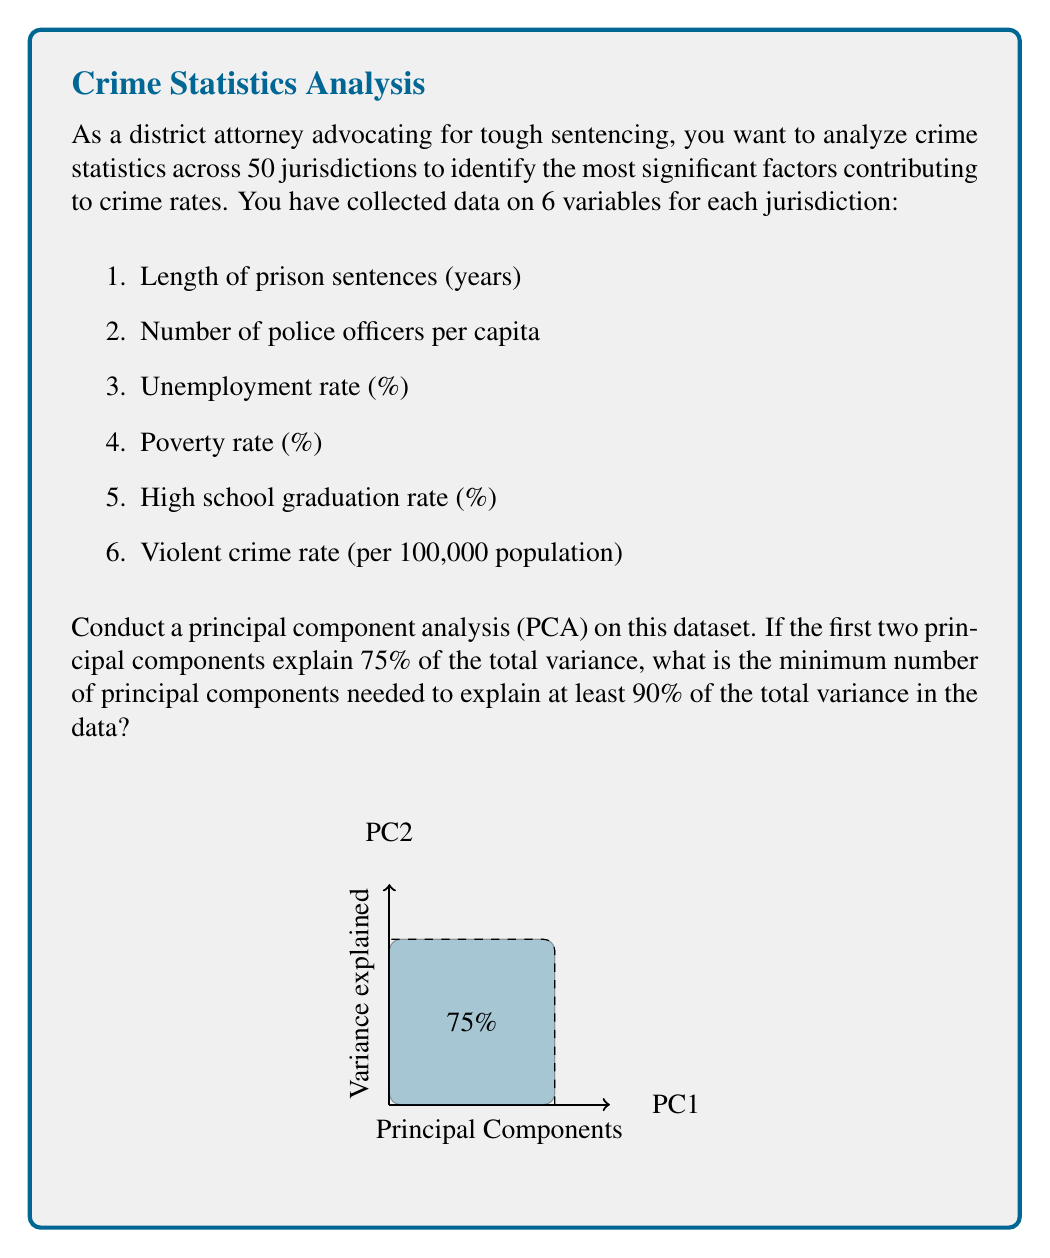Give your solution to this math problem. To solve this problem, we need to follow these steps:

1. Understand the concept of principal component analysis (PCA):
   PCA is a technique used to reduce the dimensionality of a dataset while retaining as much of the original variability as possible.

2. Interpret the given information:
   - We have 6 variables across 50 jurisdictions.
   - The first two principal components explain 75% of the total variance.

3. Calculate the remaining variance:
   - Total variance = 100%
   - Variance explained by first two PCs = 75%
   - Remaining variance = 100% - 75% = 25%

4. Determine the minimum number of additional PCs needed:
   - We need to explain at least 90% of the total variance.
   - Additional variance to be explained = 90% - 75% = 15%
   - Let's assume each subsequent PC explains half the variance of the previous one:
     
     $$\text{PC3} = 25\% \times 0.5 = 12.5\%$$
     $$\text{PC4} = 12.5\% \times 0.5 = 6.25\%$$

   - PC3 alone is not enough (75% + 12.5% = 87.5% < 90%)
   - PC3 + PC4 is sufficient (75% + 12.5% + 6.25% = 93.75% > 90%)

5. Count the total number of PCs needed:
   - First two PCs + two additional PCs = 4 PCs in total

Therefore, a minimum of 4 principal components are needed to explain at least 90% of the total variance in the crime statistics data.
Answer: 4 principal components 